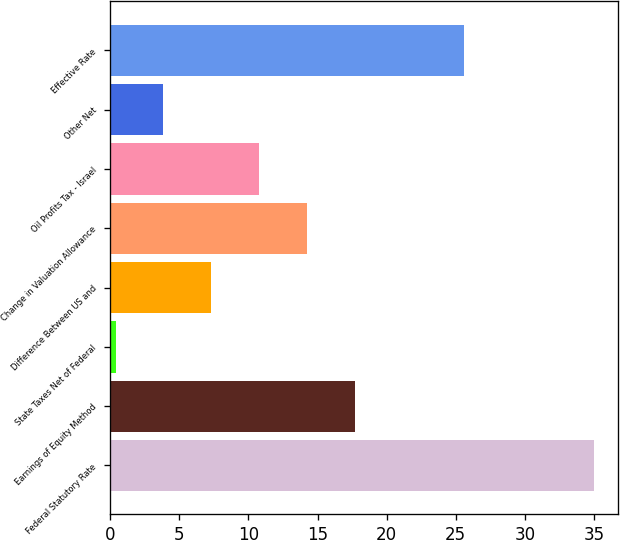<chart> <loc_0><loc_0><loc_500><loc_500><bar_chart><fcel>Federal Statutory Rate<fcel>Earnings of Equity Method<fcel>State Taxes Net of Federal<fcel>Difference Between US and<fcel>Change in Valuation Allowance<fcel>Oil Profits Tax - Israel<fcel>Other Net<fcel>Effective Rate<nl><fcel>35<fcel>17.7<fcel>0.4<fcel>7.32<fcel>14.24<fcel>10.78<fcel>3.86<fcel>25.6<nl></chart> 